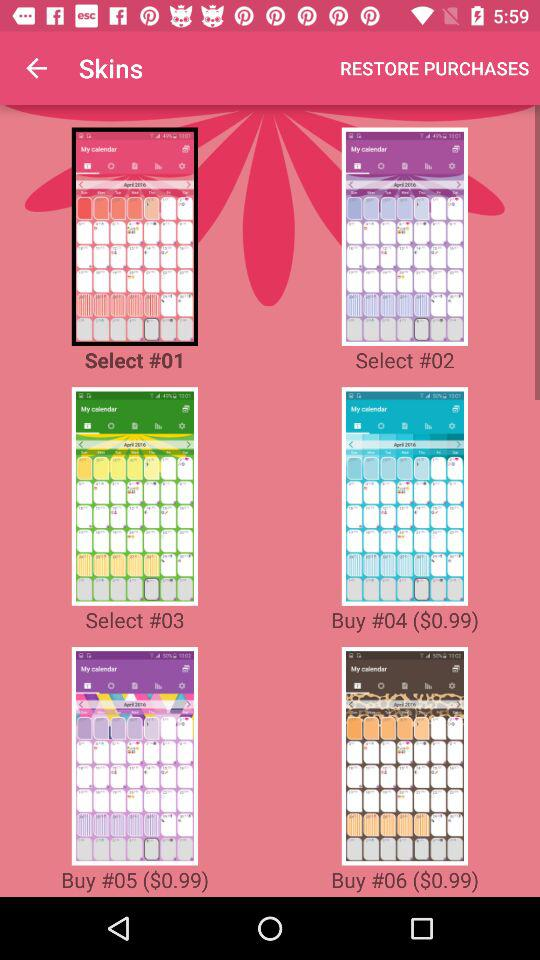What is the price of "#05"? The price of "#05" is $0.99. 